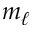<formula> <loc_0><loc_0><loc_500><loc_500>m _ { \ell }</formula> 